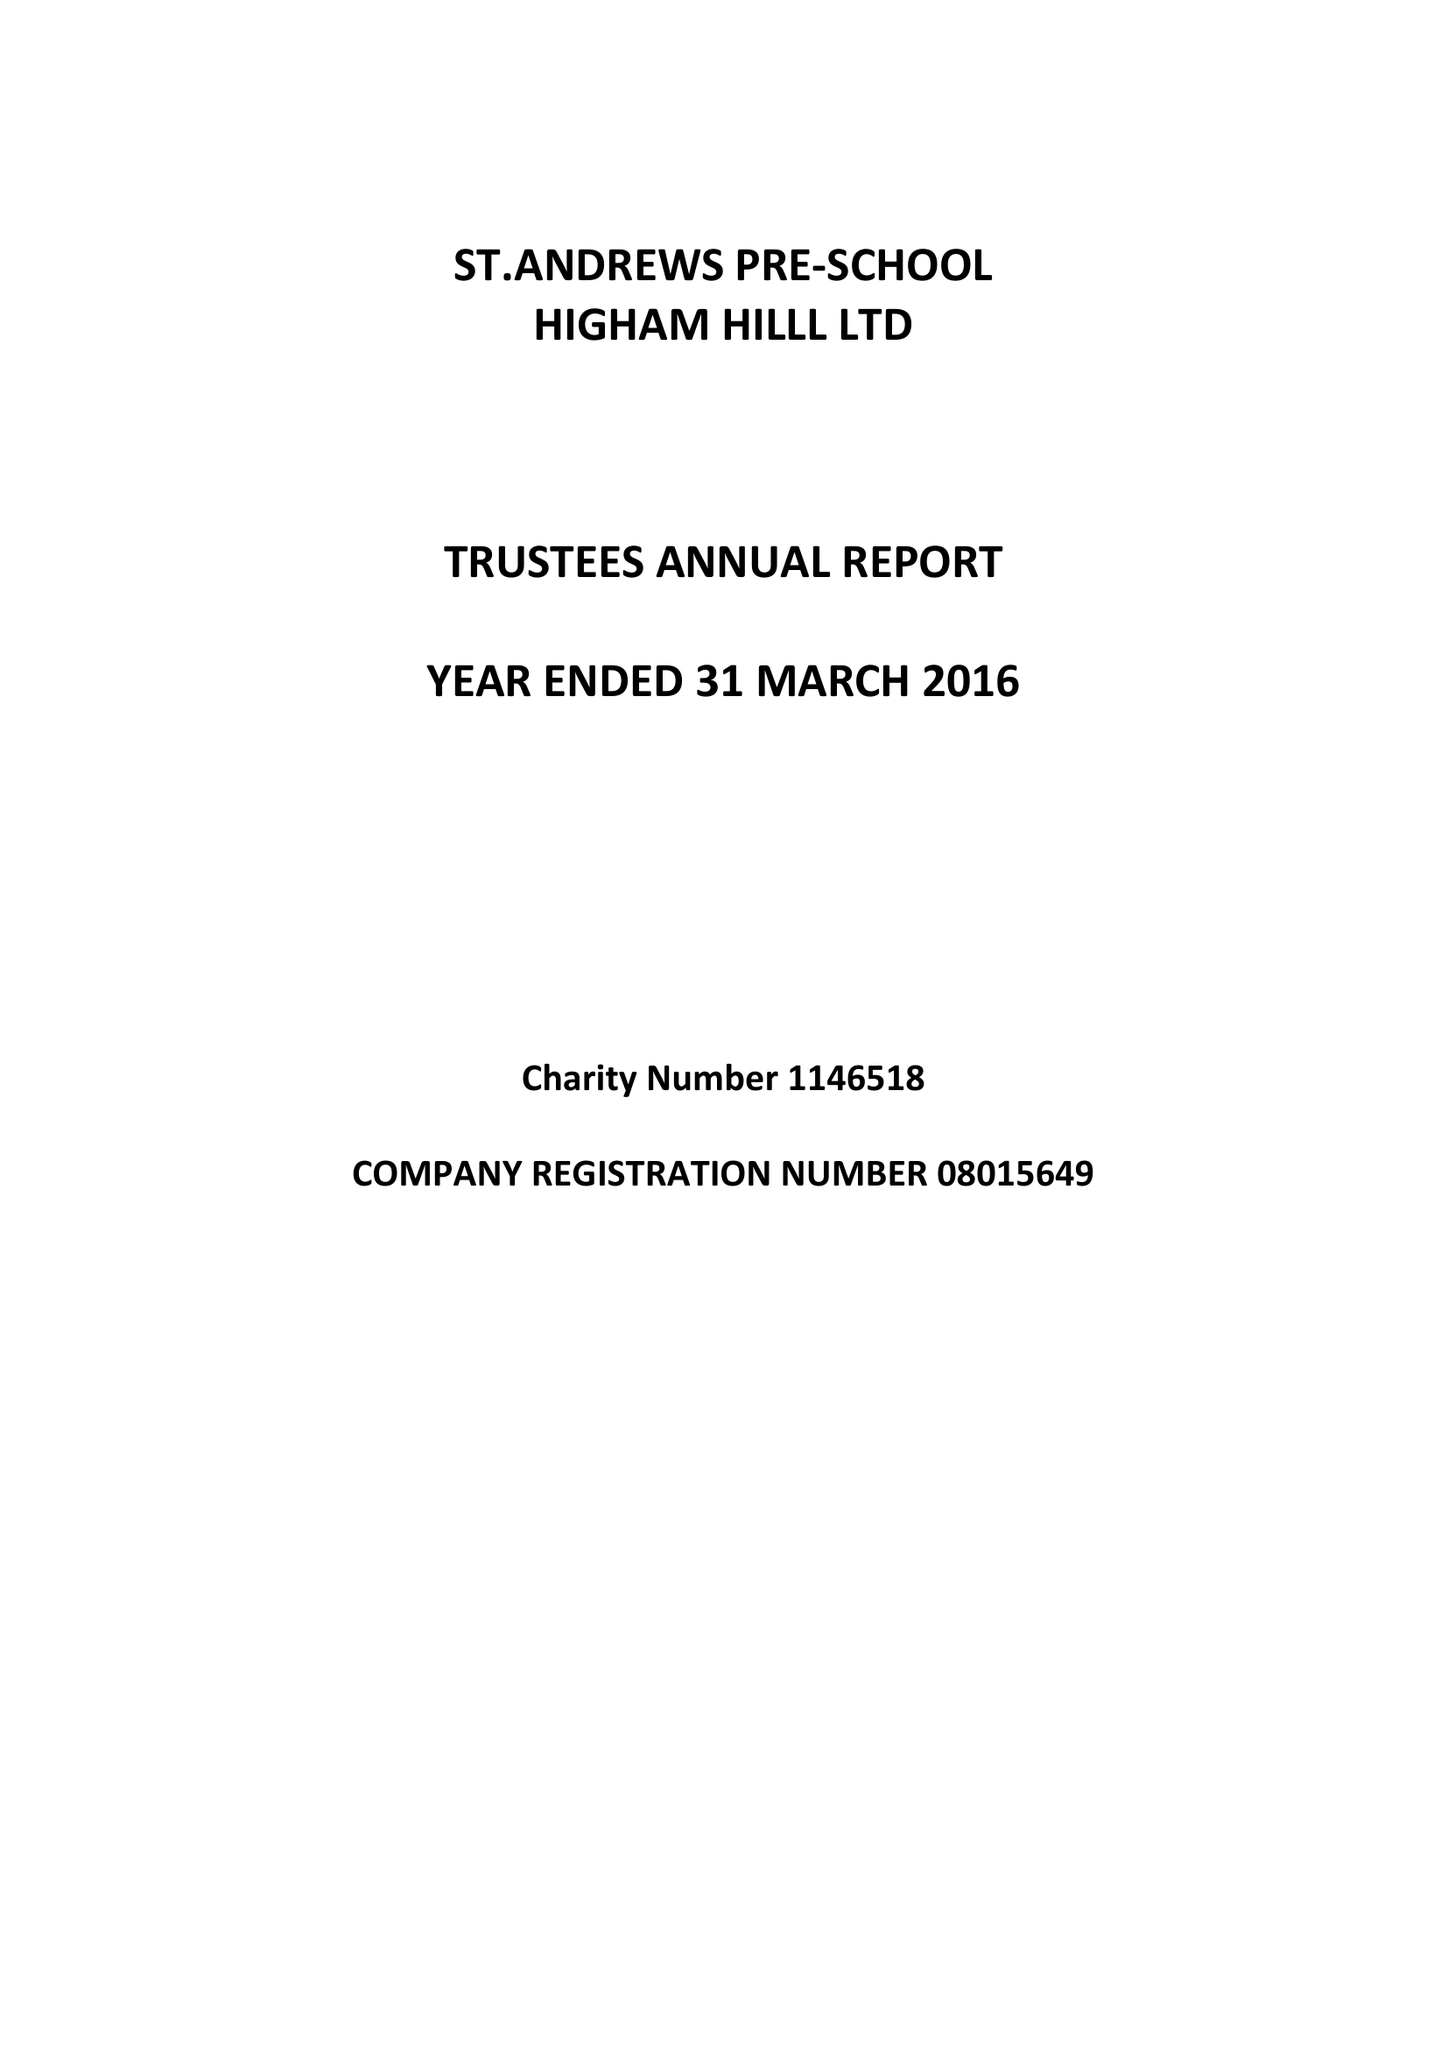What is the value for the address__post_town?
Answer the question using a single word or phrase. LONDON 